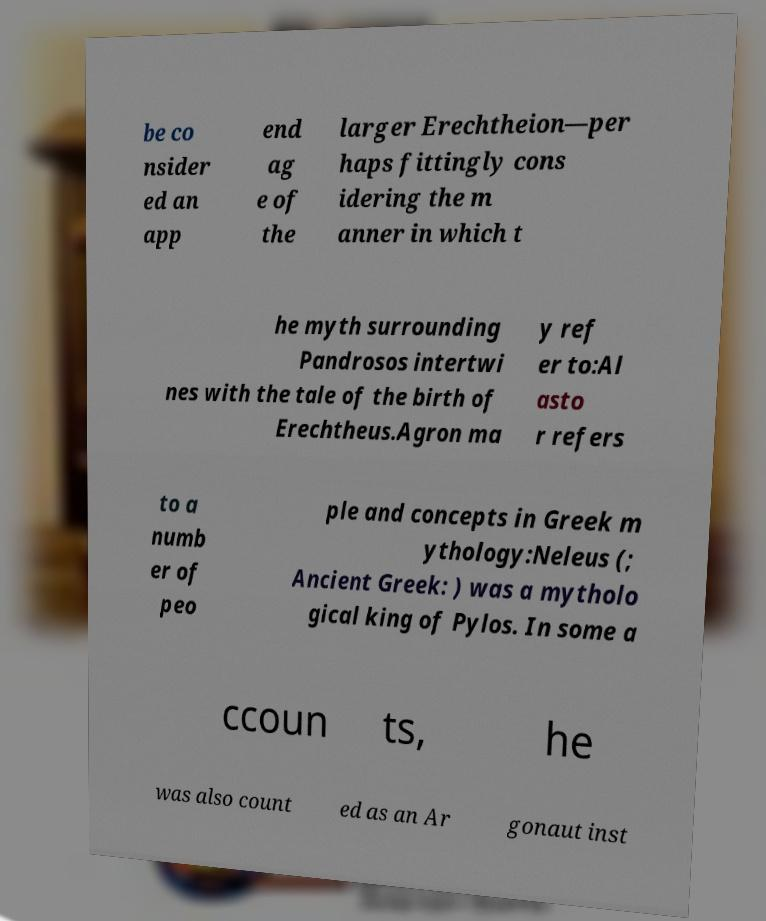Please read and relay the text visible in this image. What does it say? be co nsider ed an app end ag e of the larger Erechtheion—per haps fittingly cons idering the m anner in which t he myth surrounding Pandrosos intertwi nes with the tale of the birth of Erechtheus.Agron ma y ref er to:Al asto r refers to a numb er of peo ple and concepts in Greek m ythology:Neleus (; Ancient Greek: ) was a mytholo gical king of Pylos. In some a ccoun ts, he was also count ed as an Ar gonaut inst 